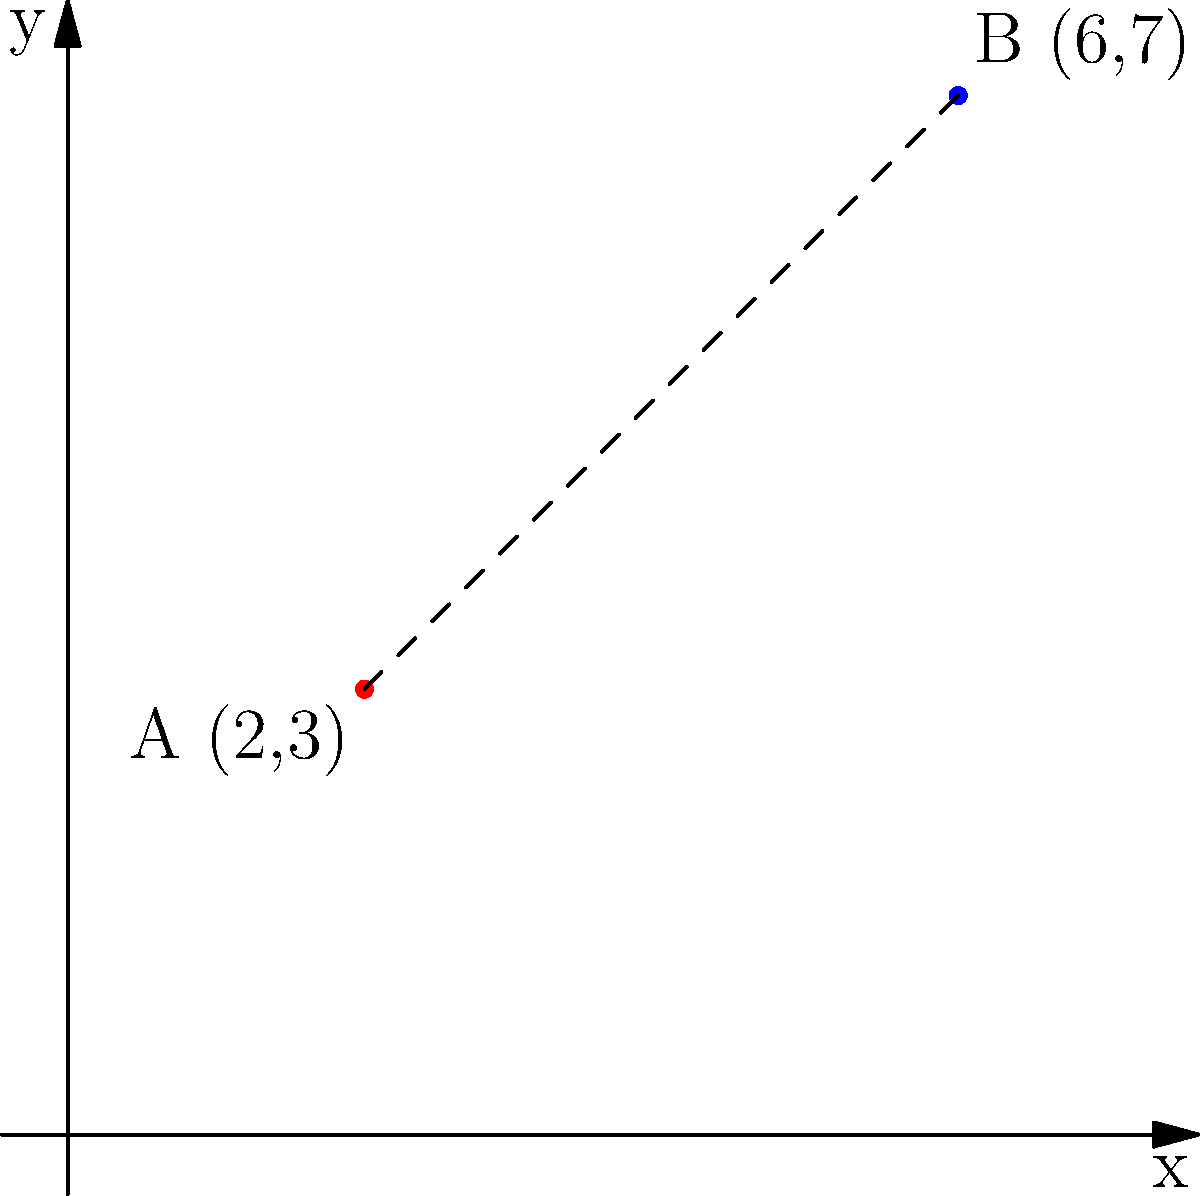In your still life painting setup, you've placed two objects: a red apple at point A(2,3) and a blue vase at point B(6,7) on your canvas grid. Calculate the distance between these two objects to ensure proper composition. Round your answer to two decimal places. To find the distance between two points, we can use the distance formula, which is derived from the Pythagorean theorem:

$$d = \sqrt{(x_2 - x_1)^2 + (y_2 - y_1)^2}$$

Where $(x_1, y_1)$ are the coordinates of the first point and $(x_2, y_2)$ are the coordinates of the second point.

Let's plug in our values:
- Point A (apple): $(x_1, y_1) = (2, 3)$
- Point B (vase): $(x_2, y_2) = (6, 7)$

Now, let's calculate:

1) $d = \sqrt{(6 - 2)^2 + (7 - 3)^2}$

2) $d = \sqrt{4^2 + 4^2}$

3) $d = \sqrt{16 + 16}$

4) $d = \sqrt{32}$

5) $d \approx 5.66$ (rounded to two decimal places)

Therefore, the distance between the apple and the vase in your painting setup is approximately 5.66 units on your canvas grid.
Answer: 5.66 units 